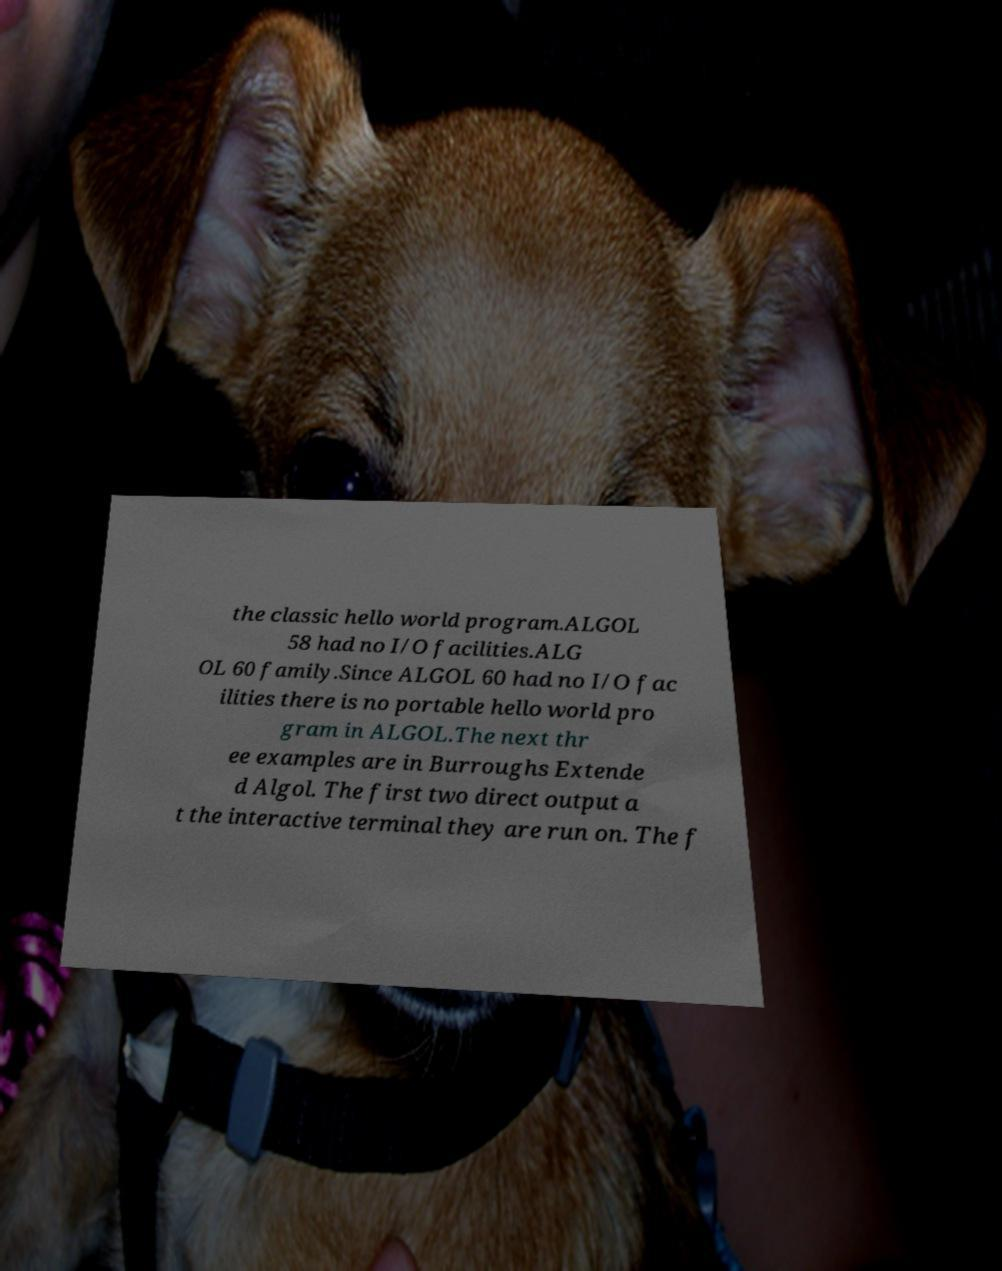For documentation purposes, I need the text within this image transcribed. Could you provide that? the classic hello world program.ALGOL 58 had no I/O facilities.ALG OL 60 family.Since ALGOL 60 had no I/O fac ilities there is no portable hello world pro gram in ALGOL.The next thr ee examples are in Burroughs Extende d Algol. The first two direct output a t the interactive terminal they are run on. The f 